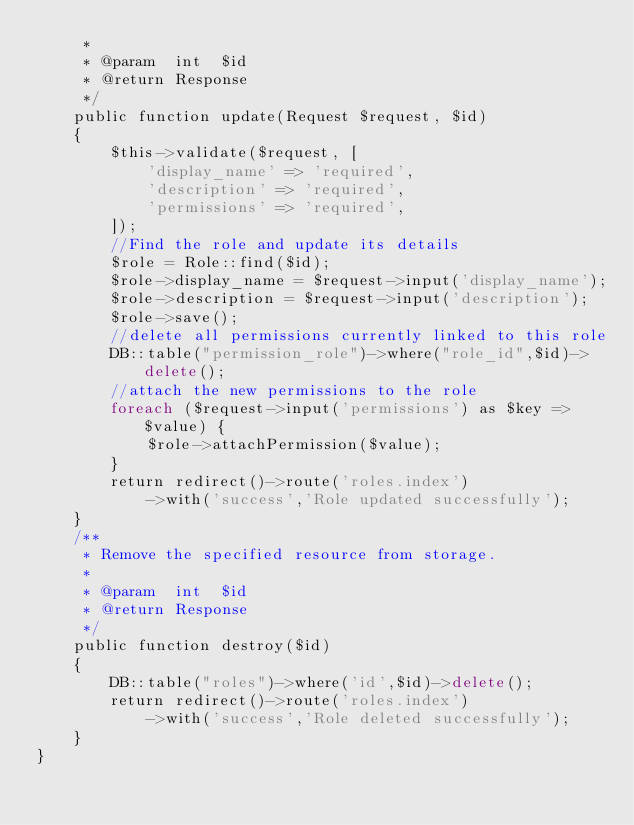Convert code to text. <code><loc_0><loc_0><loc_500><loc_500><_PHP_>     *
     * @param  int  $id
     * @return Response
     */
    public function update(Request $request, $id)
    {
        $this->validate($request, [
            'display_name' => 'required',
            'description' => 'required',
            'permissions' => 'required',
        ]);
        //Find the role and update its details
        $role = Role::find($id);
        $role->display_name = $request->input('display_name');
        $role->description = $request->input('description');
        $role->save();
        //delete all permissions currently linked to this role
        DB::table("permission_role")->where("role_id",$id)->delete();
        //attach the new permissions to the role
        foreach ($request->input('permissions') as $key => $value) {
            $role->attachPermission($value);
        }
        return redirect()->route('roles.index')
            ->with('success','Role updated successfully');
    }
    /**
     * Remove the specified resource from storage.
     *
     * @param  int  $id
     * @return Response
     */
    public function destroy($id)
    {
        DB::table("roles")->where('id',$id)->delete();
        return redirect()->route('roles.index')
            ->with('success','Role deleted successfully');
    }
}
</code> 